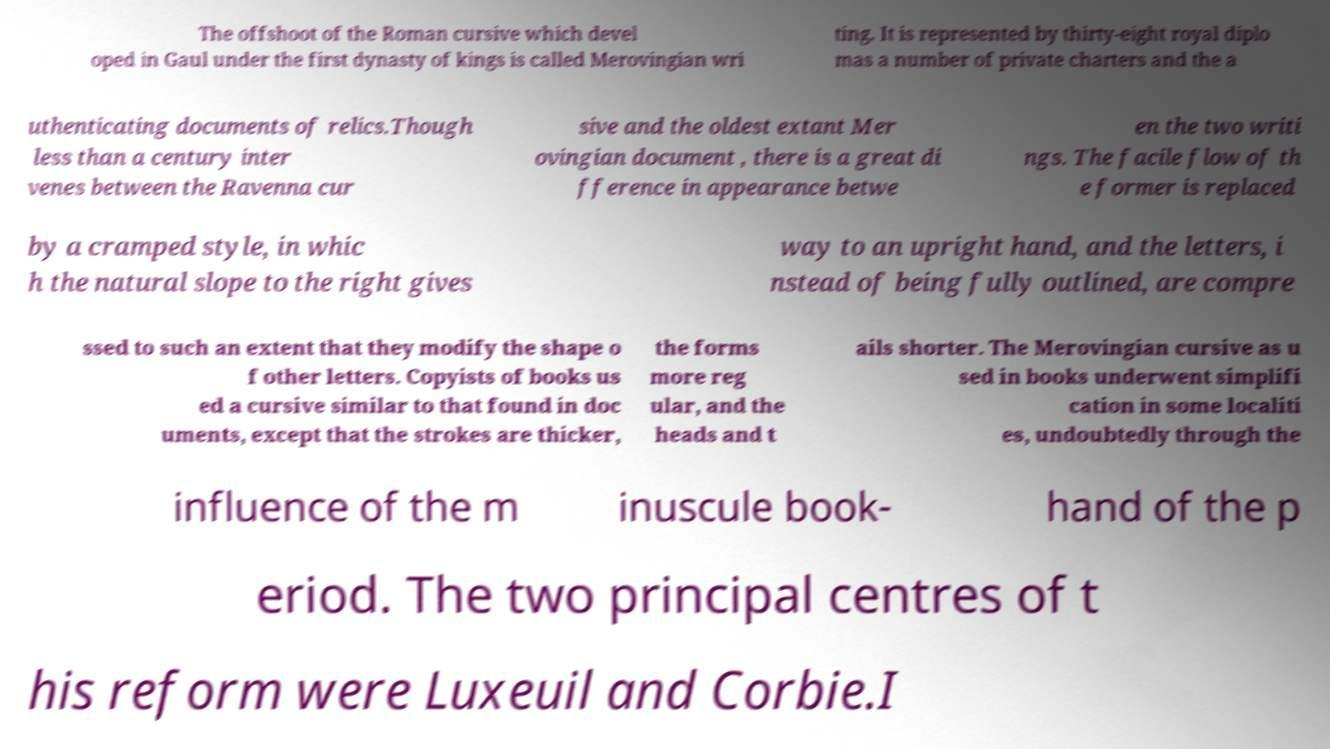Can you read and provide the text displayed in the image?This photo seems to have some interesting text. Can you extract and type it out for me? The offshoot of the Roman cursive which devel oped in Gaul under the first dynasty of kings is called Merovingian wri ting. It is represented by thirty-eight royal diplo mas a number of private charters and the a uthenticating documents of relics.Though less than a century inter venes between the Ravenna cur sive and the oldest extant Mer ovingian document , there is a great di fference in appearance betwe en the two writi ngs. The facile flow of th e former is replaced by a cramped style, in whic h the natural slope to the right gives way to an upright hand, and the letters, i nstead of being fully outlined, are compre ssed to such an extent that they modify the shape o f other letters. Copyists of books us ed a cursive similar to that found in doc uments, except that the strokes are thicker, the forms more reg ular, and the heads and t ails shorter. The Merovingian cursive as u sed in books underwent simplifi cation in some localiti es, undoubtedly through the influence of the m inuscule book- hand of the p eriod. The two principal centres of t his reform were Luxeuil and Corbie.I 